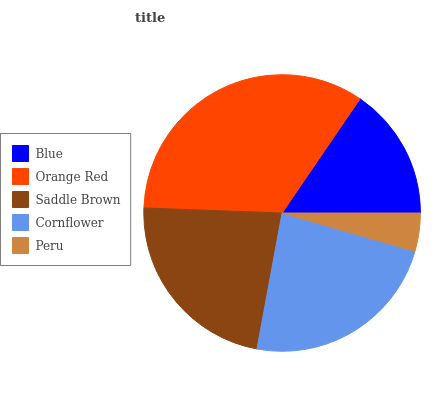Is Peru the minimum?
Answer yes or no. Yes. Is Orange Red the maximum?
Answer yes or no. Yes. Is Saddle Brown the minimum?
Answer yes or no. No. Is Saddle Brown the maximum?
Answer yes or no. No. Is Orange Red greater than Saddle Brown?
Answer yes or no. Yes. Is Saddle Brown less than Orange Red?
Answer yes or no. Yes. Is Saddle Brown greater than Orange Red?
Answer yes or no. No. Is Orange Red less than Saddle Brown?
Answer yes or no. No. Is Saddle Brown the high median?
Answer yes or no. Yes. Is Saddle Brown the low median?
Answer yes or no. Yes. Is Peru the high median?
Answer yes or no. No. Is Orange Red the low median?
Answer yes or no. No. 